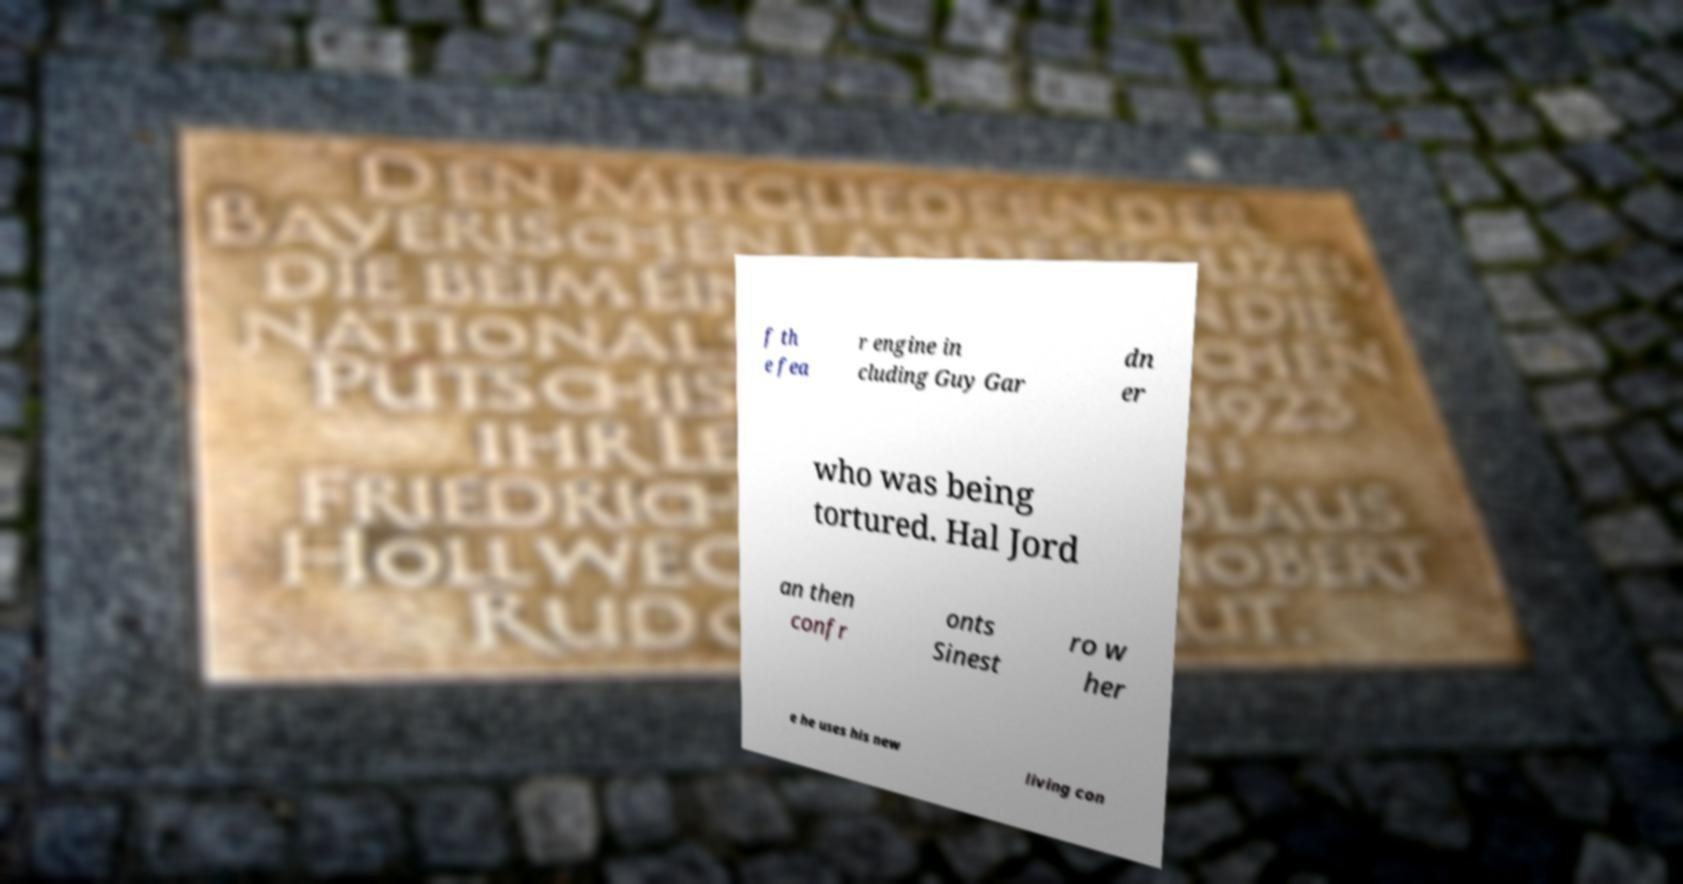Please read and relay the text visible in this image. What does it say? f th e fea r engine in cluding Guy Gar dn er who was being tortured. Hal Jord an then confr onts Sinest ro w her e he uses his new living con 